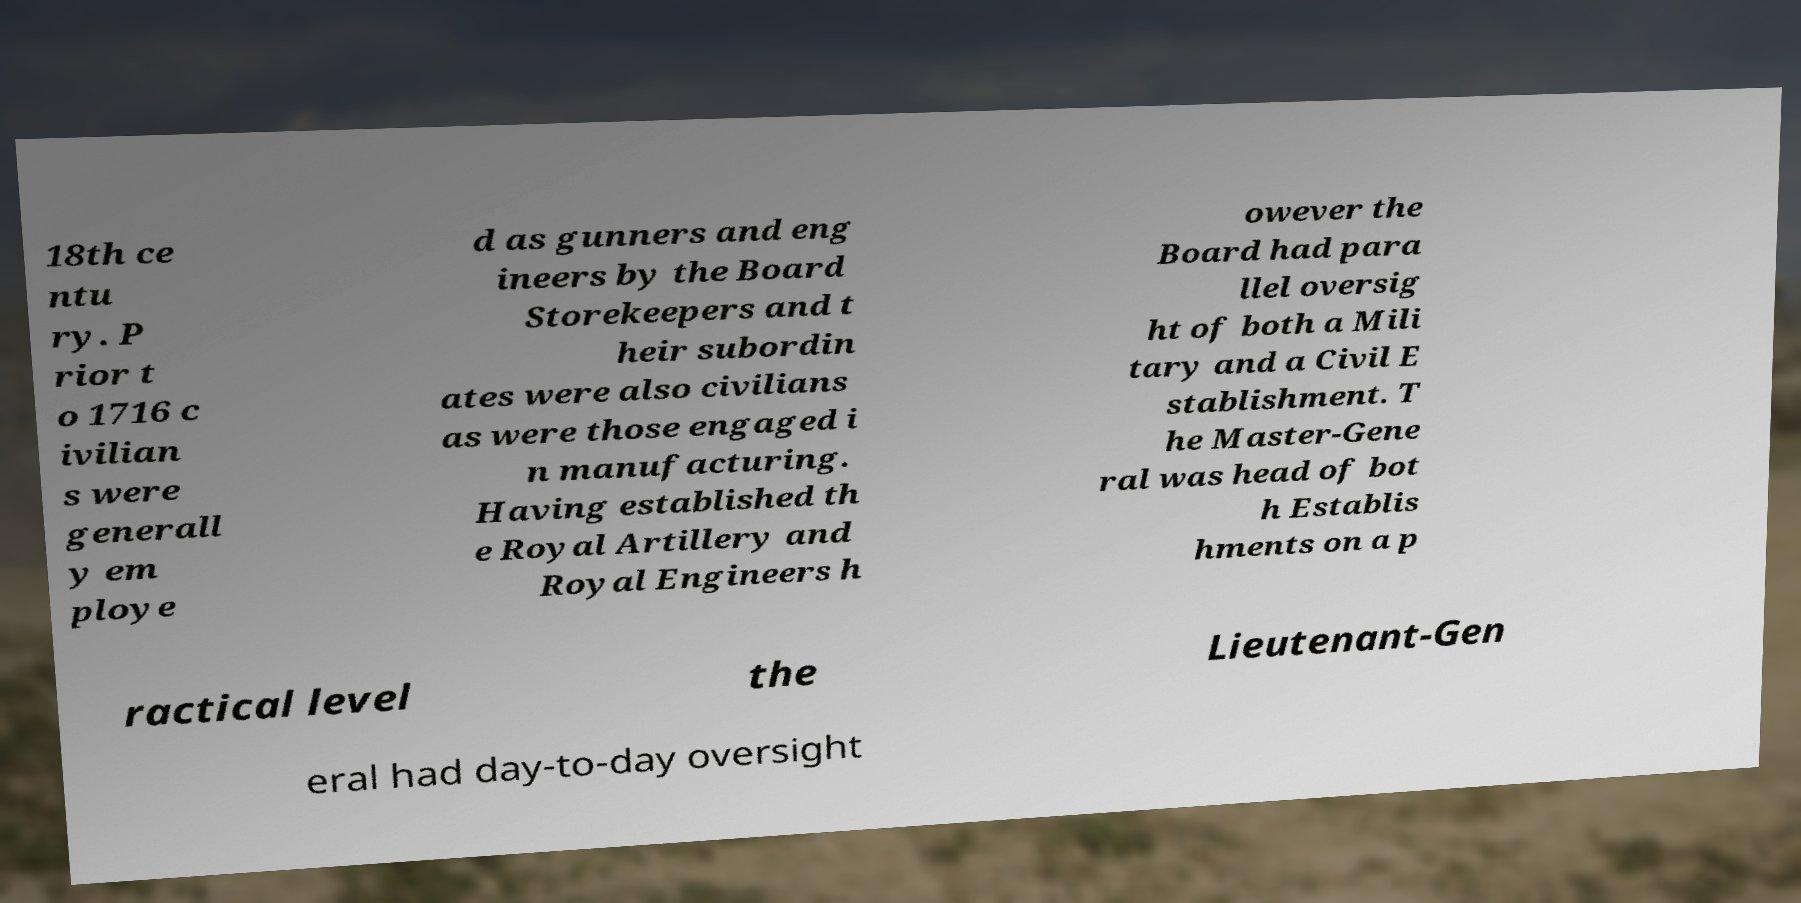I need the written content from this picture converted into text. Can you do that? 18th ce ntu ry. P rior t o 1716 c ivilian s were generall y em ploye d as gunners and eng ineers by the Board Storekeepers and t heir subordin ates were also civilians as were those engaged i n manufacturing. Having established th e Royal Artillery and Royal Engineers h owever the Board had para llel oversig ht of both a Mili tary and a Civil E stablishment. T he Master-Gene ral was head of bot h Establis hments on a p ractical level the Lieutenant-Gen eral had day-to-day oversight 